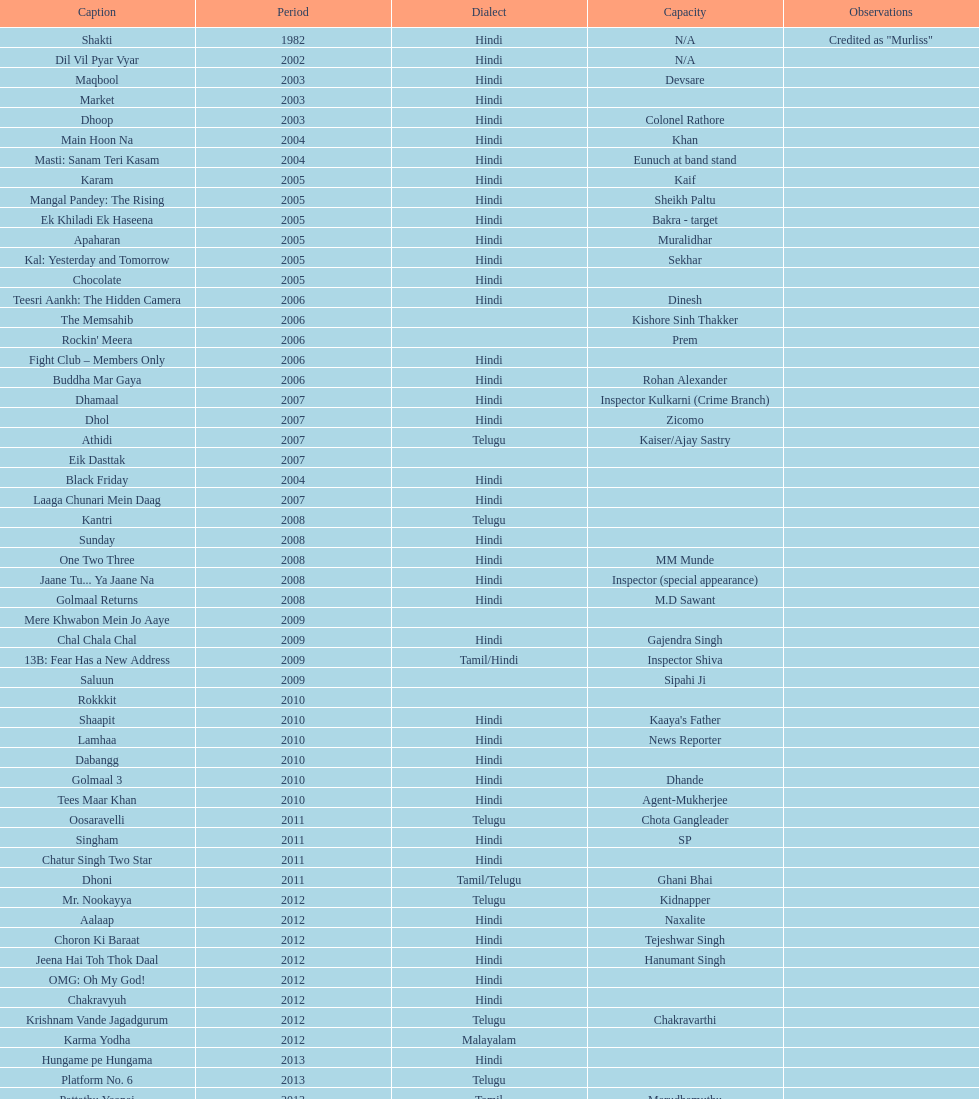How many roles has this actor had? 36. 